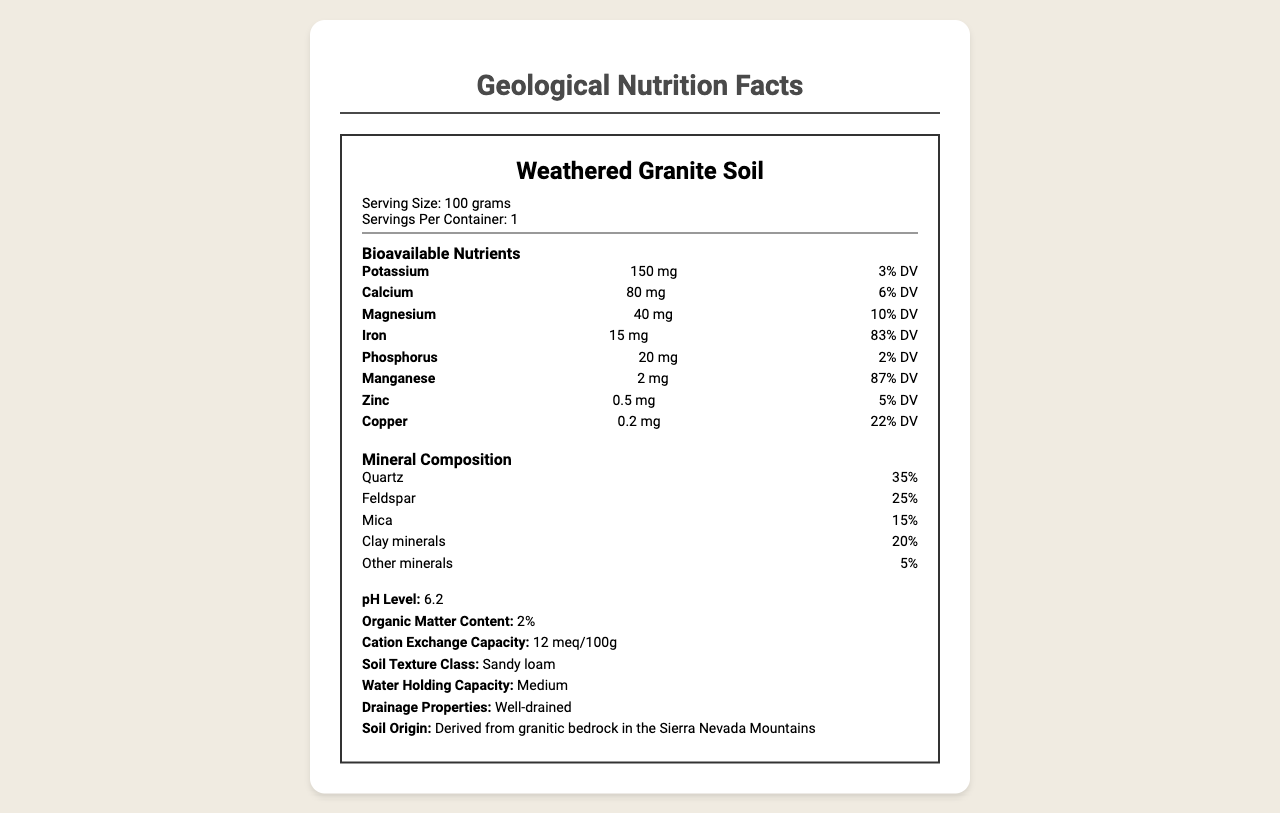what is the serving size of the Weathered Granite Soil? The document states that the serving size is 100 grams.
Answer: 100 grams how much Potassium is available per serving? The document lists 150 mg of Potassium per serving.
Answer: 150 mg what is the daily value percentage of Iron in Weathered Granite Soil? The document shows that Iron has a daily value percentage of 83%.
Answer: 83% which mineral makes up the largest percentage of the mineral composition? The document indicates that Quartz makes up 35% of the mineral composition.
Answer: Quartz what is the pH level of the Weathered Granite Soil? The pH level is listed as 6.2 in the document.
Answer: 6.2 which of the following minerals is not mentioned in the mineral composition? A. Quartz B. Feldspar C. Hematite The document lists Quartz, Feldspar, Mica, Clay minerals, and Other minerals, but not Hematite.
Answer: C. Hematite what practices are recommended for conserving the Weathered Granite Soil? The document lists Contour plowing, Cover cropping, and Minimal tillage as conservation practices.
Answer: Contour plowing, Cover cropping, Minimal tillage is Weathered Granite Soil suitable for growing vineyards? The document states that it is suitable for vineyards.
Answer: Yes summarize the main idea of the document. The document comprehensively outlines the characteristics of Weathered Granite Soil including nutrient content, mineral composition, pH level, and agricultural suitability, emphasizing its viability for specific crops and the best practices for soil conservation.
Answer: The document provides a detailed nutritional and compositional analysis of Weathered Granite Soil, showing the bioavailable nutrients, mineral composition, soil properties, and its suitability for agriculture, along with recommended conservation practices. what types of weathering processes contribute to the formation of Weathered Granite Soil? The document lists physical weathering through freeze-thaw cycles, chemical weathering by carbonic acid in rainwater, and biological weathering by plant roots and soil microorganisms.
Answer: Physical weathering, Chemical weathering, Biological weathering which nutrient has the highest daily value percentage? A. Potassium B. Calcium C. Iron D. Manganese The document shows that Manganese has a daily value percentage of 87%, which is the highest.
Answer: D. Manganese what is the total percentage of Clay minerals in the composition? The document specifies that Clay minerals make up 20% of the composition.
Answer: 20% can the document tell us the exact percentage of organic matter in Weathered Granite Soil? The document states that the organic matter content is 2%.
Answer: Yes what is the average temperature in the environmental factors section? The document lists the average temperature as 12°C.
Answer: 12°C are root crops mentioned as suitable for Weathered Granite Soil? The document states that Weathered Granite Soil is good for root crops with proper management.
Answer: Yes how many bioavailable nutrients are listed in the document? The document lists 8 bioavailable nutrients: Potassium, Calcium, Magnesium, Iron, Phosphorus, Manganese, Zinc, and Copper.
Answer: 8 where is Weathered Granite Soil derived from? The document states that the soil is derived from granitic bedrock in the Sierra Nevada Mountains.
Answer: Granitic bedrock in the Sierra Nevada Mountains what is the water holding capacity of this soil? The document lists the water holding capacity as Medium.
Answer: Medium what is the cation exchange capacity of Weathered Granite Soil? The document specifies that the cation exchange capacity is 12 meq/100g.
Answer: 12 meq/100g how does the document describe the drainage properties of Weathered Granite Soil? The document describes the drainage properties as well-drained.
Answer: Well-drained are there any details about the specific types of clay minerals present in Weathered Granite Soil? The document simply mentions "Clay minerals" without detailing specific types.
Answer: Cannot be determined 